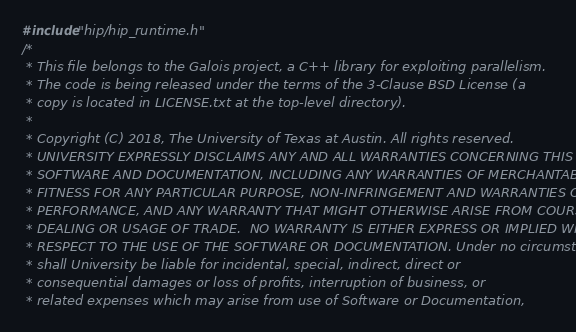<code> <loc_0><loc_0><loc_500><loc_500><_Cuda_>#include "hip/hip_runtime.h"
/*
 * This file belongs to the Galois project, a C++ library for exploiting parallelism.
 * The code is being released under the terms of the 3-Clause BSD License (a
 * copy is located in LICENSE.txt at the top-level directory).
 *
 * Copyright (C) 2018, The University of Texas at Austin. All rights reserved.
 * UNIVERSITY EXPRESSLY DISCLAIMS ANY AND ALL WARRANTIES CONCERNING THIS
 * SOFTWARE AND DOCUMENTATION, INCLUDING ANY WARRANTIES OF MERCHANTABILITY,
 * FITNESS FOR ANY PARTICULAR PURPOSE, NON-INFRINGEMENT AND WARRANTIES OF
 * PERFORMANCE, AND ANY WARRANTY THAT MIGHT OTHERWISE ARISE FROM COURSE OF
 * DEALING OR USAGE OF TRADE.  NO WARRANTY IS EITHER EXPRESS OR IMPLIED WITH
 * RESPECT TO THE USE OF THE SOFTWARE OR DOCUMENTATION. Under no circumstances
 * shall University be liable for incidental, special, indirect, direct or
 * consequential damages or loss of profits, interruption of business, or
 * related expenses which may arise from use of Software or Documentation,</code> 